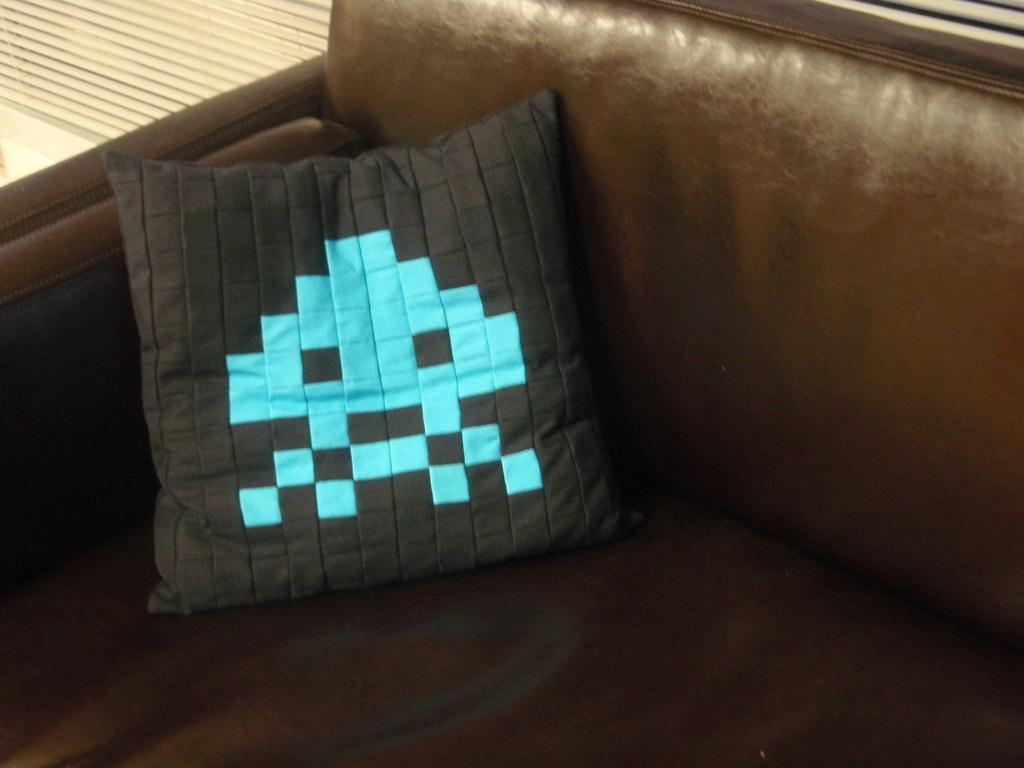Please provide a concise description of this image. In this picture we can see a sofa, on this sofa we can see a pillow and in the background we can see an object. 